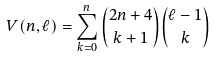<formula> <loc_0><loc_0><loc_500><loc_500>V ( n , \ell ) = \sum _ { k = 0 } ^ { n } \binom { 2 n + 4 } { k + 1 } \binom { \ell - 1 } { k }</formula> 